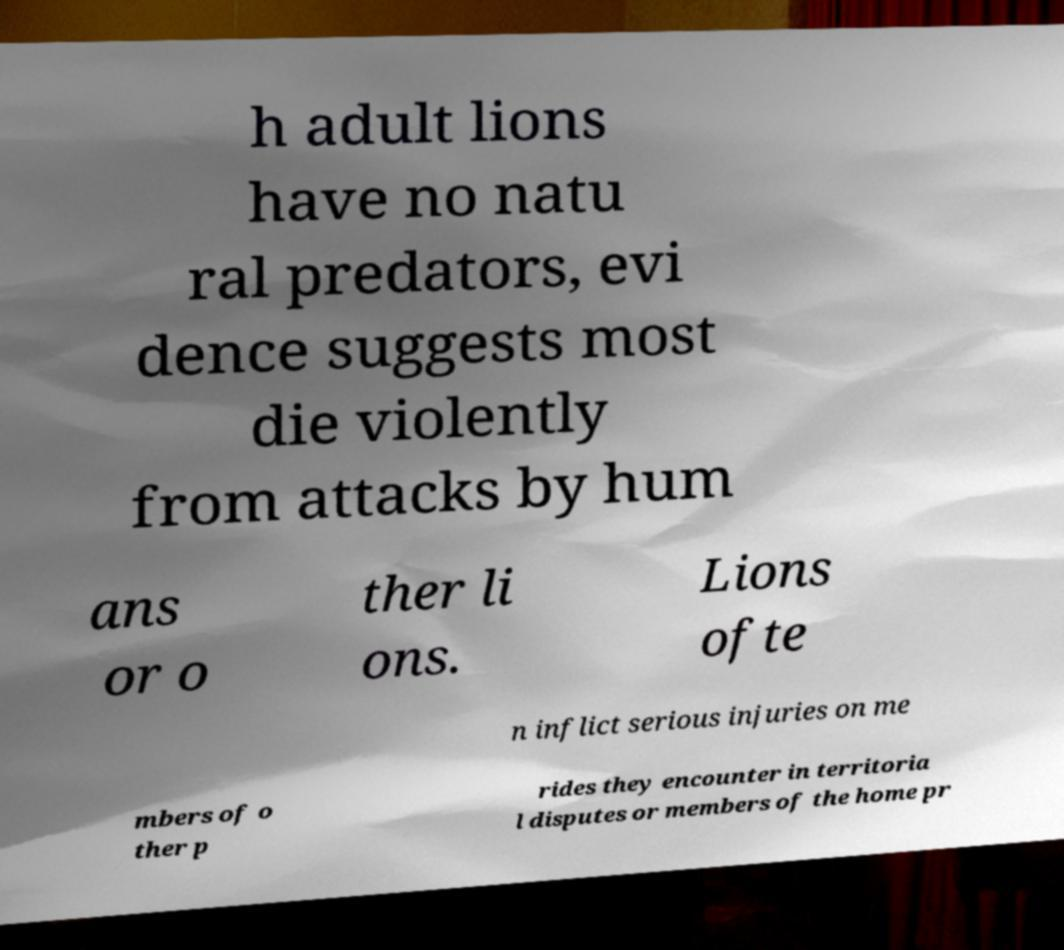What messages or text are displayed in this image? I need them in a readable, typed format. h adult lions have no natu ral predators, evi dence suggests most die violently from attacks by hum ans or o ther li ons. Lions ofte n inflict serious injuries on me mbers of o ther p rides they encounter in territoria l disputes or members of the home pr 